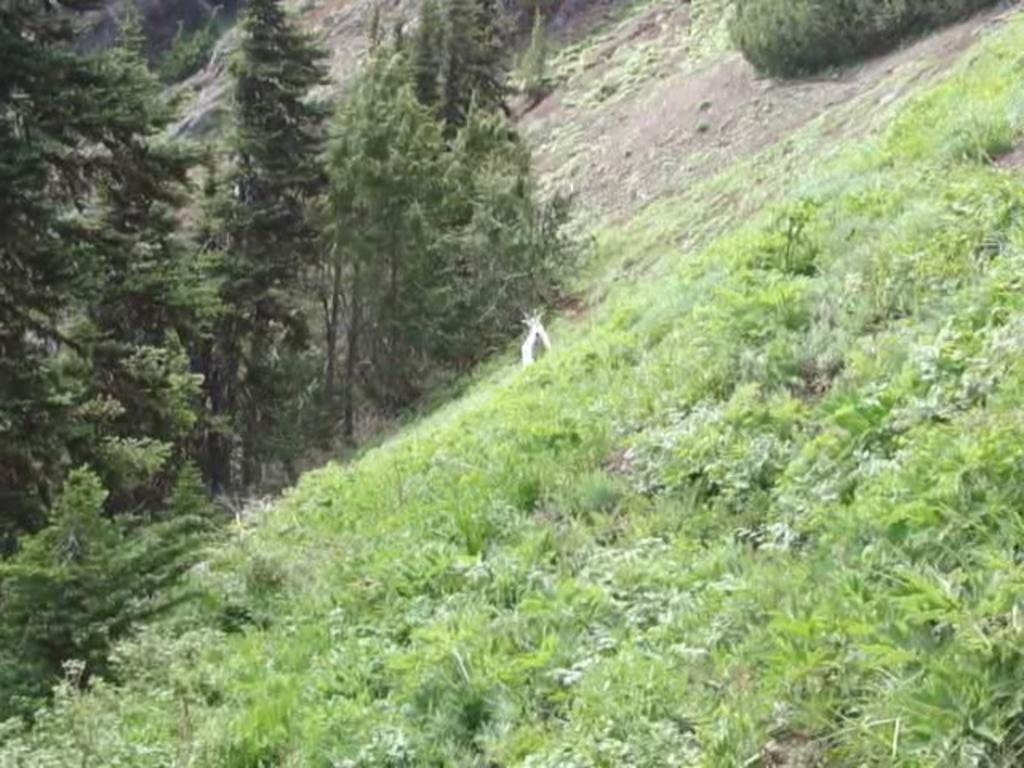What type of vegetation can be seen in the image? There is grass in the image. What part of the natural environment is visible in the image? The ground is visible in the image. What type of plants are also present in the image? There are trees in the image. Can you describe the white-colored object in the image? There is a white-colored object in the image, but its specific nature is not clear from the provided facts. What flavor of ice cream does the carpenter enjoy while sitting on the head in the image? There is no ice cream, carpenter, or head present in the image, so this scenario cannot be observed. 